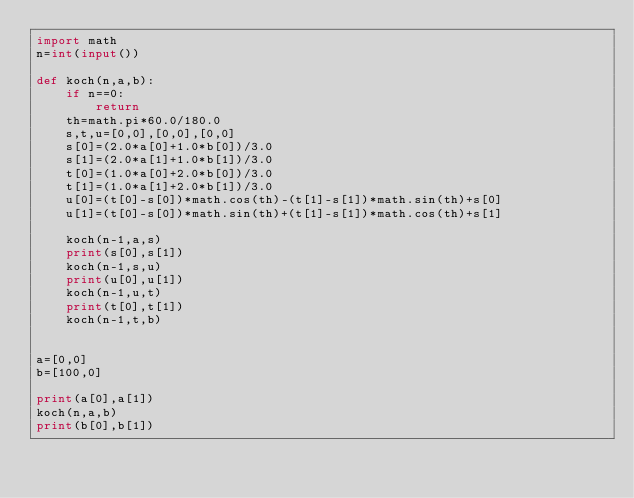<code> <loc_0><loc_0><loc_500><loc_500><_Python_>import math
n=int(input())

def koch(n,a,b):
    if n==0:
        return
    th=math.pi*60.0/180.0
    s,t,u=[0,0],[0,0],[0,0]
    s[0]=(2.0*a[0]+1.0*b[0])/3.0
    s[1]=(2.0*a[1]+1.0*b[1])/3.0
    t[0]=(1.0*a[0]+2.0*b[0])/3.0
    t[1]=(1.0*a[1]+2.0*b[1])/3.0
    u[0]=(t[0]-s[0])*math.cos(th)-(t[1]-s[1])*math.sin(th)+s[0]
    u[1]=(t[0]-s[0])*math.sin(th)+(t[1]-s[1])*math.cos(th)+s[1]

    koch(n-1,a,s)
    print(s[0],s[1])
    koch(n-1,s,u)
    print(u[0],u[1])
    koch(n-1,u,t)
    print(t[0],t[1])
    koch(n-1,t,b)


a=[0,0]
b=[100,0]

print(a[0],a[1])
koch(n,a,b)
print(b[0],b[1])

</code> 